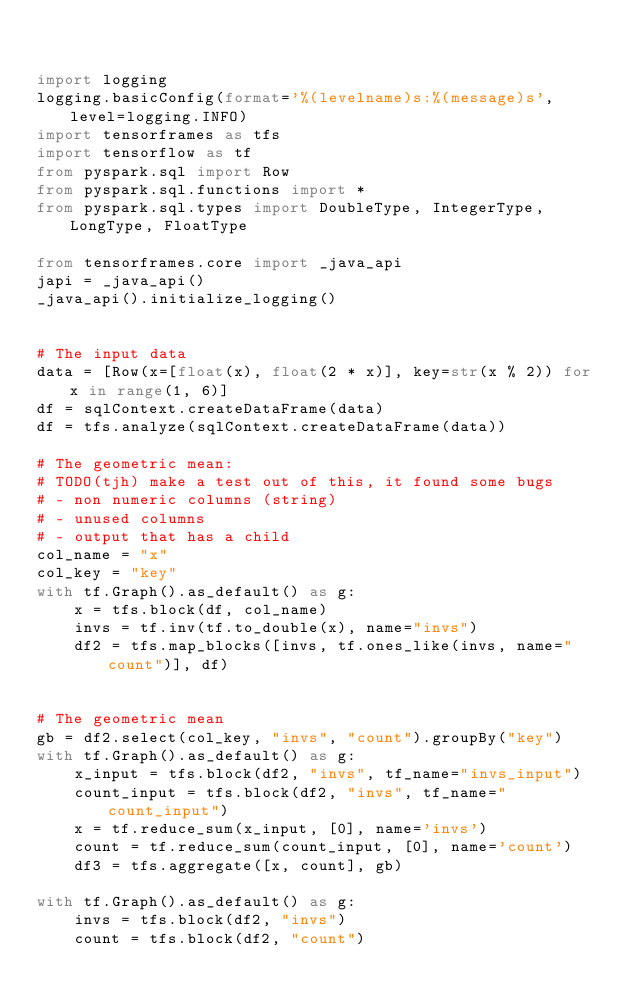Convert code to text. <code><loc_0><loc_0><loc_500><loc_500><_Python_>

import logging
logging.basicConfig(format='%(levelname)s:%(message)s', level=logging.INFO)
import tensorframes as tfs
import tensorflow as tf
from pyspark.sql import Row
from pyspark.sql.functions import *
from pyspark.sql.types import DoubleType, IntegerType, LongType, FloatType

from tensorframes.core import _java_api
japi = _java_api()
_java_api().initialize_logging()


# The input data
data = [Row(x=[float(x), float(2 * x)], key=str(x % 2)) for x in range(1, 6)]
df = sqlContext.createDataFrame(data)
df = tfs.analyze(sqlContext.createDataFrame(data))

# The geometric mean:
# TODO(tjh) make a test out of this, it found some bugs
# - non numeric columns (string)
# - unused columns
# - output that has a child
col_name = "x"
col_key = "key"
with tf.Graph().as_default() as g:
    x = tfs.block(df, col_name)
    invs = tf.inv(tf.to_double(x), name="invs")
    df2 = tfs.map_blocks([invs, tf.ones_like(invs, name="count")], df)


# The geometric mean
gb = df2.select(col_key, "invs", "count").groupBy("key")
with tf.Graph().as_default() as g:
    x_input = tfs.block(df2, "invs", tf_name="invs_input")
    count_input = tfs.block(df2, "invs", tf_name="count_input")
    x = tf.reduce_sum(x_input, [0], name='invs')
    count = tf.reduce_sum(count_input, [0], name='count')
    df3 = tfs.aggregate([x, count], gb)

with tf.Graph().as_default() as g:
    invs = tfs.block(df2, "invs")
    count = tfs.block(df2, "count")</code> 